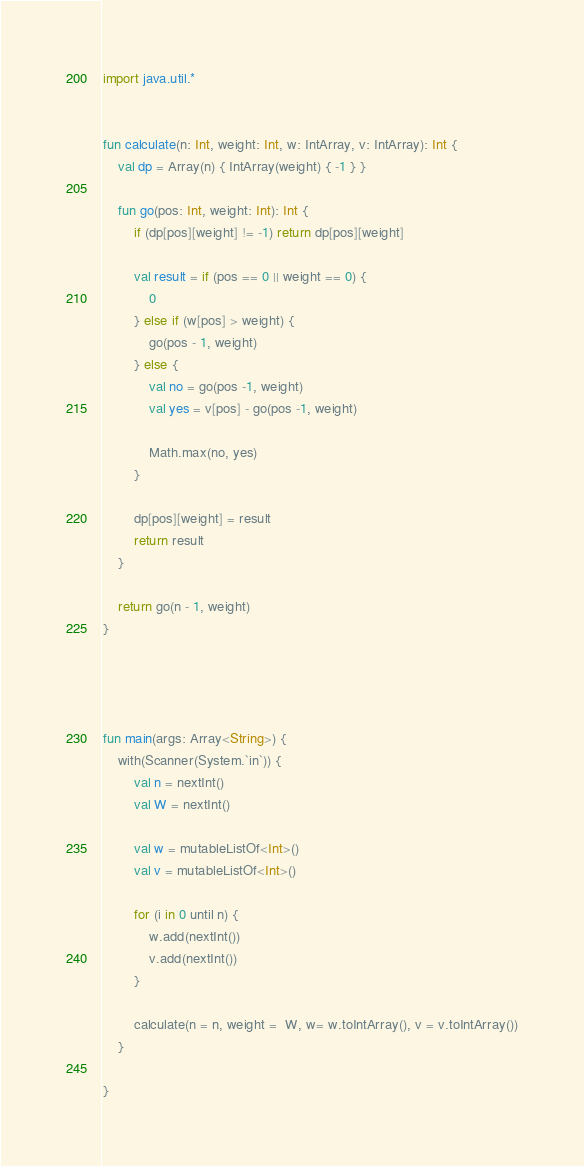Convert code to text. <code><loc_0><loc_0><loc_500><loc_500><_Kotlin_>
import java.util.*


fun calculate(n: Int, weight: Int, w: IntArray, v: IntArray): Int {
    val dp = Array(n) { IntArray(weight) { -1 } }

    fun go(pos: Int, weight: Int): Int {
        if (dp[pos][weight] != -1) return dp[pos][weight]

        val result = if (pos == 0 || weight == 0) {
            0
        } else if (w[pos] > weight) {
            go(pos - 1, weight)
        } else {
            val no = go(pos -1, weight)
            val yes = v[pos] - go(pos -1, weight)

            Math.max(no, yes)
        }

        dp[pos][weight] = result
        return result
    }

    return go(n - 1, weight)
}




fun main(args: Array<String>) {
    with(Scanner(System.`in`)) {
        val n = nextInt()
        val W = nextInt()

        val w = mutableListOf<Int>()
        val v = mutableListOf<Int>()

        for (i in 0 until n) {
            w.add(nextInt())
            v.add(nextInt())
        }

        calculate(n = n, weight =  W, w= w.toIntArray(), v = v.toIntArray())
    }

}</code> 